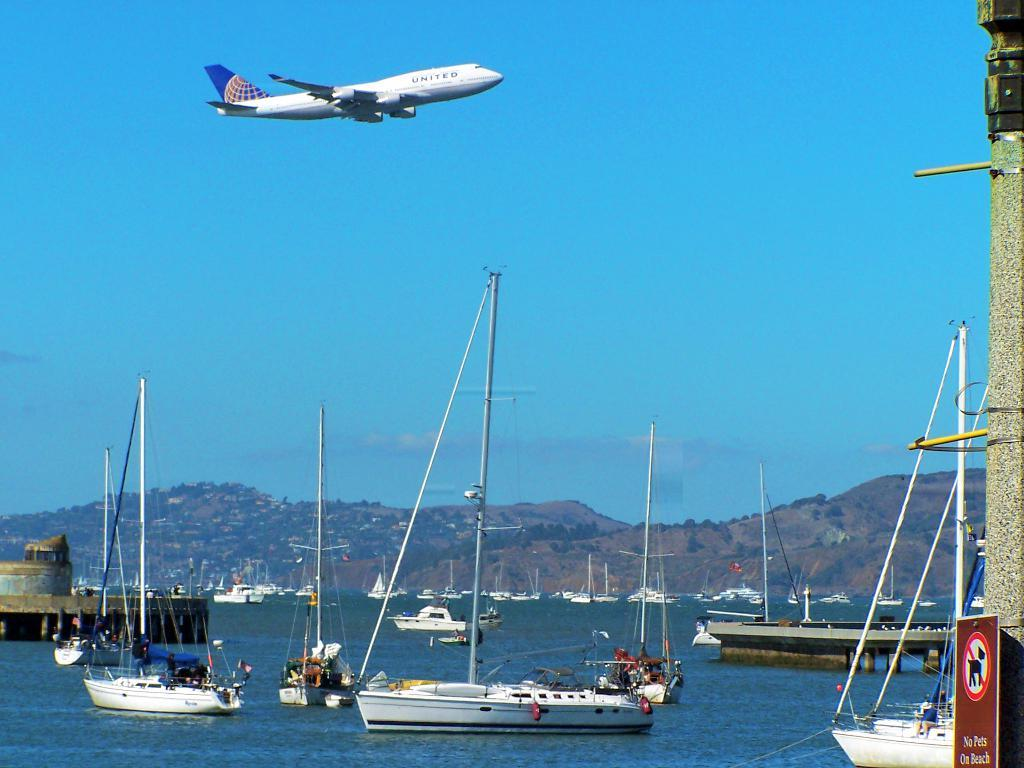<image>
Describe the image concisely. An airplane with United written on the side flying over a bunch of boats 